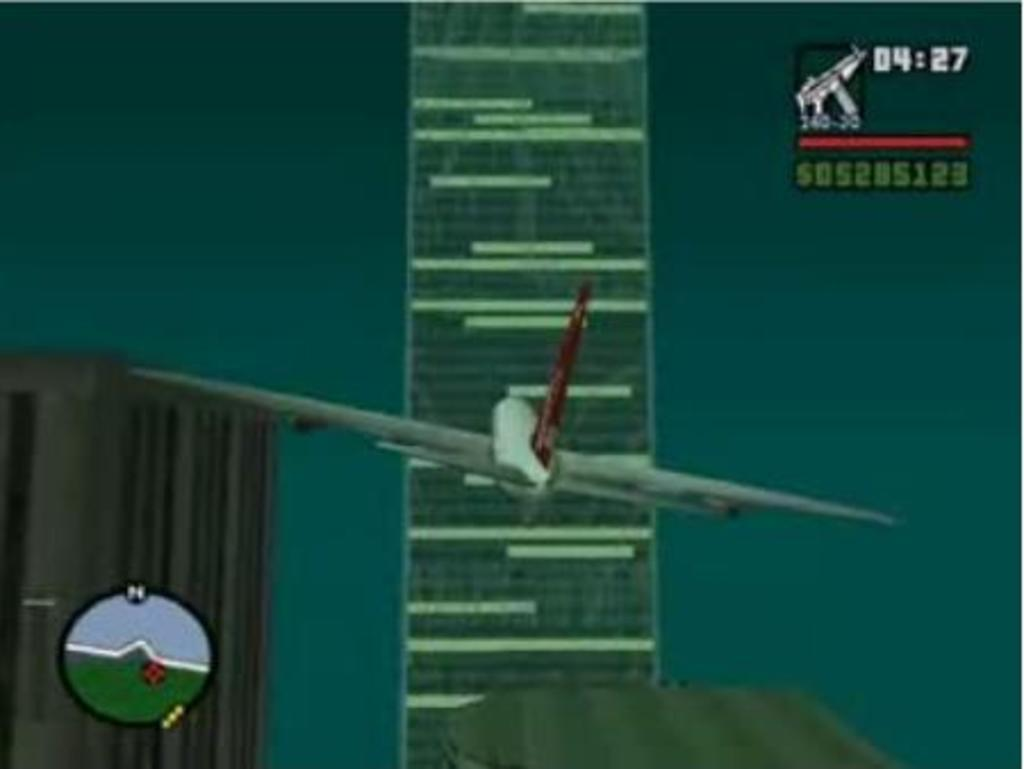Provide a one-sentence caption for the provided image. A plane in a video game is flying toward a building with a timer showing 04:27. 